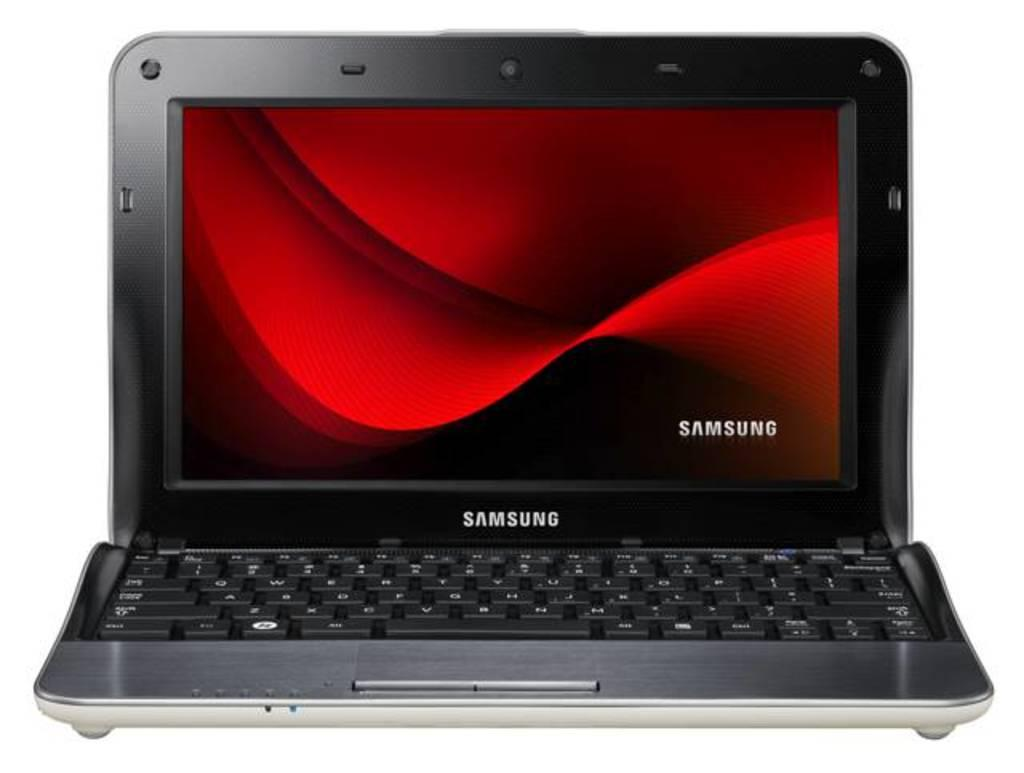<image>
Share a concise interpretation of the image provided. A laptop with a red screen and the word Samsung on the bottle 